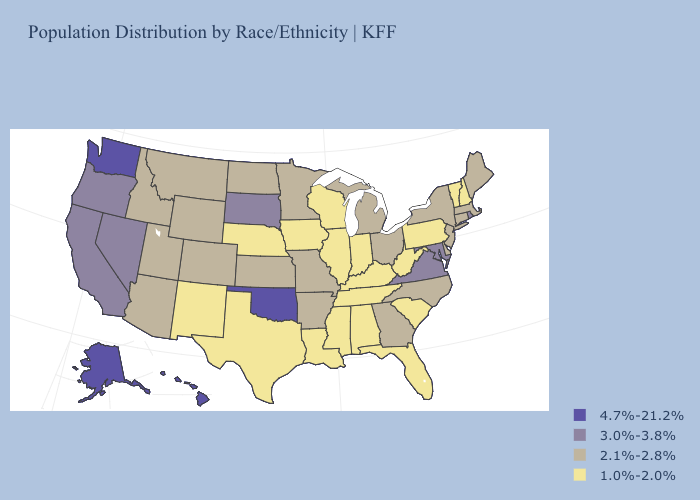What is the value of Maryland?
Short answer required. 3.0%-3.8%. Does Wisconsin have the lowest value in the USA?
Keep it brief. Yes. Name the states that have a value in the range 3.0%-3.8%?
Concise answer only. California, Maryland, Nevada, Oregon, Rhode Island, South Dakota, Virginia. What is the value of Tennessee?
Concise answer only. 1.0%-2.0%. Which states hav the highest value in the Northeast?
Concise answer only. Rhode Island. What is the value of New Hampshire?
Answer briefly. 1.0%-2.0%. What is the highest value in states that border Maine?
Be succinct. 1.0%-2.0%. What is the value of Oregon?
Answer briefly. 3.0%-3.8%. What is the lowest value in the MidWest?
Write a very short answer. 1.0%-2.0%. Does the first symbol in the legend represent the smallest category?
Give a very brief answer. No. What is the value of Indiana?
Short answer required. 1.0%-2.0%. What is the value of Mississippi?
Be succinct. 1.0%-2.0%. Does Ohio have the lowest value in the USA?
Write a very short answer. No. What is the highest value in states that border Tennessee?
Write a very short answer. 3.0%-3.8%. What is the value of Colorado?
Answer briefly. 2.1%-2.8%. 